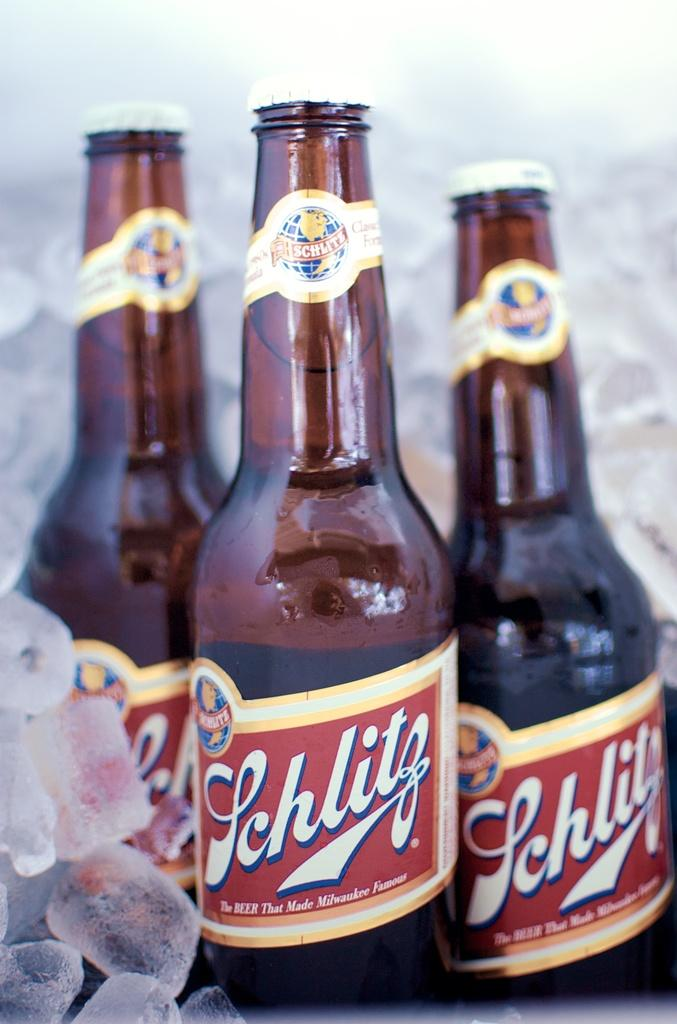How many wine bottles are visible in the image? There are three wine bottles in the image. What is located beside the wine bottles? There are ice cubes beside the wine bottles. Can you describe the background of the image? There are ice cubes in the background of the image. What type of experience does the jail offer in the image? There is no jail present in the image, so it is not possible to answer that question. 